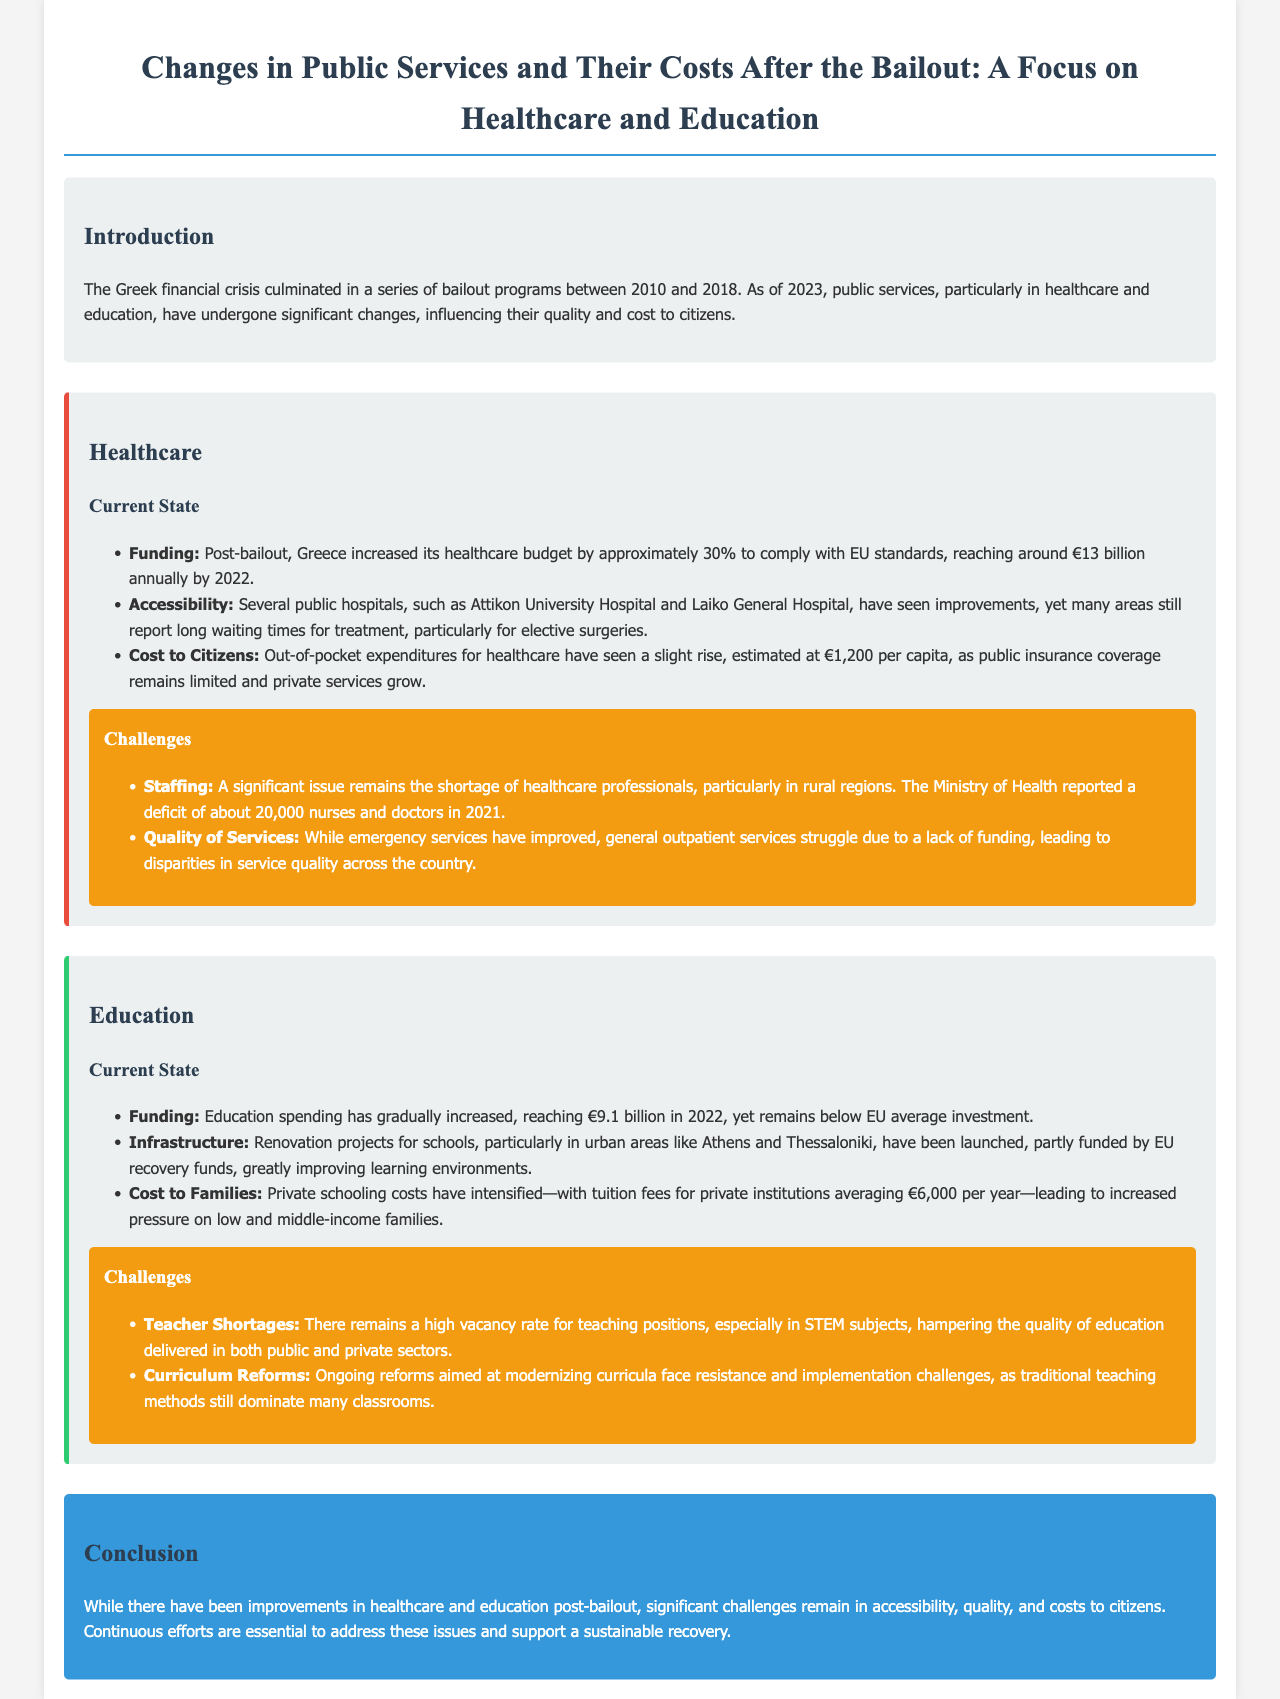What was the increase in healthcare budget post-bailout? The healthcare budget increased by approximately 30% to around €13 billion annually by 2022.
Answer: €13 billion What is the estimated out-of-pocket expenditure for healthcare per capita? The document states that out-of-pocket expenditures for healthcare are estimated at €1,200 per capita.
Answer: €1,200 How much did education spending reach in 2022? The education spending reached €9.1 billion in 2022.
Answer: €9.1 billion What is the average tuition fee for private institutions? The average tuition fee for private institutions is €6,000 per year.
Answer: €6,000 What major issue remains in healthcare staffing? A significant issue remains the shortage of healthcare professionals, particularly in rural regions.
Answer: Shortage of healthcare professionals What challenge is faced regarding teacher vacancies? There remains a high vacancy rate for teaching positions, especially in STEM subjects.
Answer: High vacancy rate What improvements have been made to school infrastructure? Renovation projects for schools have been launched, partly funded by EU recovery funds.
Answer: Renovation projects What is one of the ongoing issues with curriculum reforms? Ongoing reforms face resistance and implementation challenges, as traditional teaching methods still dominate many classrooms.
Answer: Resistance and implementation challenges 